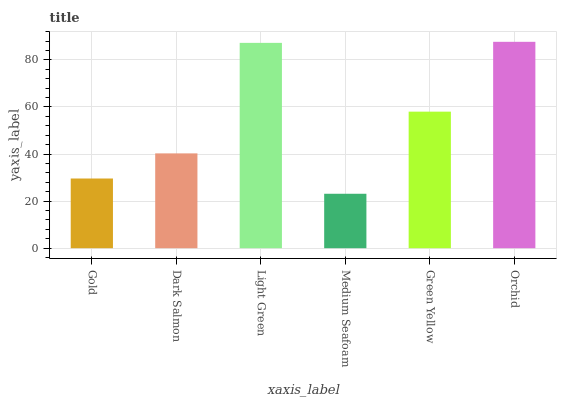Is Dark Salmon the minimum?
Answer yes or no. No. Is Dark Salmon the maximum?
Answer yes or no. No. Is Dark Salmon greater than Gold?
Answer yes or no. Yes. Is Gold less than Dark Salmon?
Answer yes or no. Yes. Is Gold greater than Dark Salmon?
Answer yes or no. No. Is Dark Salmon less than Gold?
Answer yes or no. No. Is Green Yellow the high median?
Answer yes or no. Yes. Is Dark Salmon the low median?
Answer yes or no. Yes. Is Orchid the high median?
Answer yes or no. No. Is Orchid the low median?
Answer yes or no. No. 